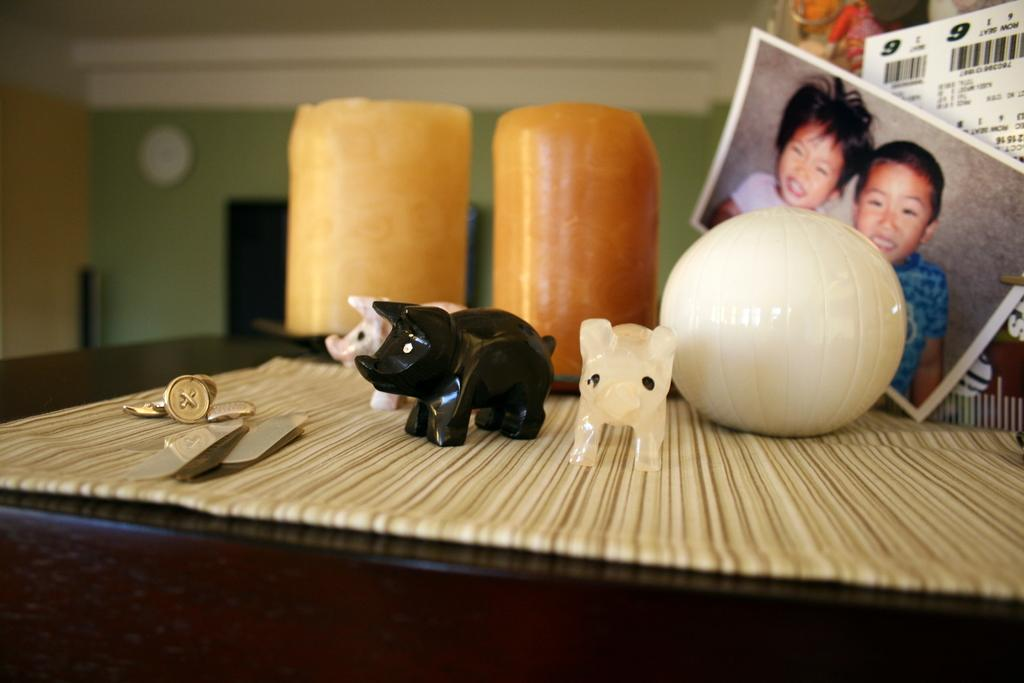What is the main piece of furniture in the image? There is a table in the image. What items can be seen on the table? There are toys and multiple photos on the table. Can you describe the photo on the table? There is a photo on the table, but the image does not provide enough detail to describe its content. What type of timekeeping device is on the left side of the table? There is a wall clock on the left side of the table. How does the pollution affect the toys on the table in the image? There is no mention of pollution in the image, and therefore it cannot be determined how it affects the toys on the table. 